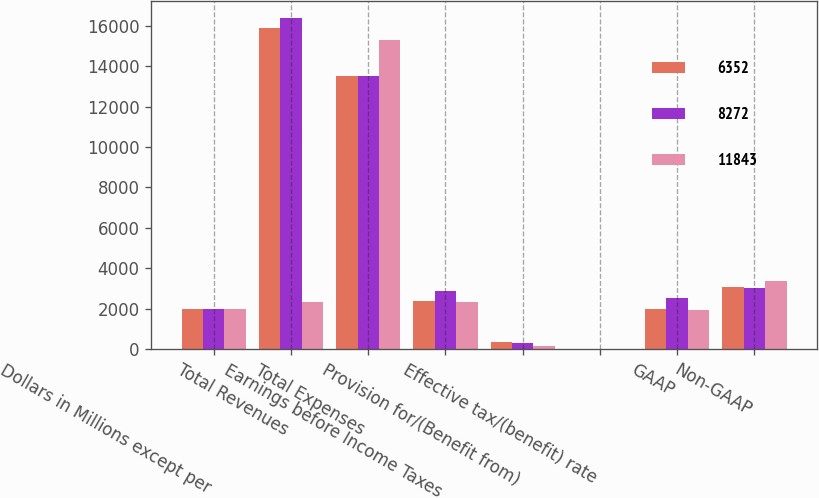Convert chart to OTSL. <chart><loc_0><loc_0><loc_500><loc_500><stacked_bar_chart><ecel><fcel>Dollars in Millions except per<fcel>Total Revenues<fcel>Total Expenses<fcel>Earnings before Income Taxes<fcel>Provision for/(Benefit from)<fcel>Effective tax/(benefit) rate<fcel>GAAP<fcel>Non-GAAP<nl><fcel>6352<fcel>2014<fcel>15879<fcel>13498<fcel>2381<fcel>352<fcel>14.8<fcel>2004<fcel>3085<nl><fcel>8272<fcel>2013<fcel>16385<fcel>13494<fcel>2891<fcel>311<fcel>10.8<fcel>2563<fcel>3019<nl><fcel>11843<fcel>2012<fcel>2340<fcel>15281<fcel>2340<fcel>161<fcel>6.9<fcel>1960<fcel>3364<nl></chart> 